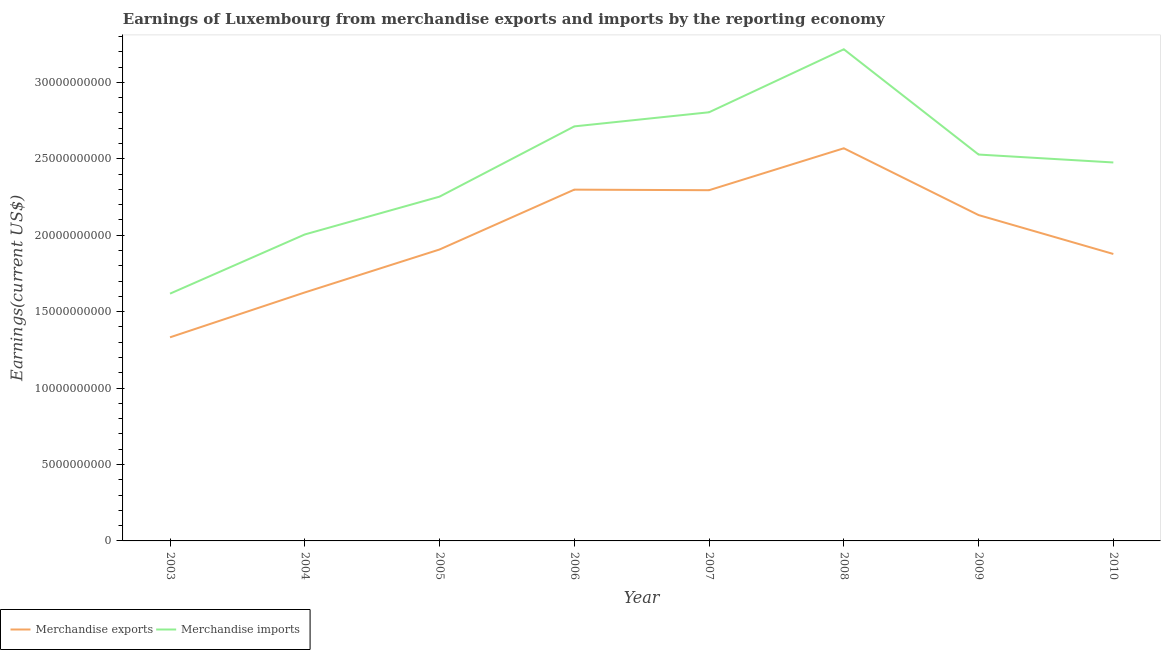How many different coloured lines are there?
Your answer should be very brief. 2. What is the earnings from merchandise imports in 2008?
Your answer should be compact. 3.22e+1. Across all years, what is the maximum earnings from merchandise imports?
Offer a terse response. 3.22e+1. Across all years, what is the minimum earnings from merchandise imports?
Your answer should be very brief. 1.62e+1. In which year was the earnings from merchandise imports maximum?
Make the answer very short. 2008. In which year was the earnings from merchandise exports minimum?
Provide a succinct answer. 2003. What is the total earnings from merchandise exports in the graph?
Your answer should be very brief. 1.60e+11. What is the difference between the earnings from merchandise exports in 2004 and that in 2008?
Provide a short and direct response. -9.43e+09. What is the difference between the earnings from merchandise imports in 2007 and the earnings from merchandise exports in 2010?
Your response must be concise. 9.27e+09. What is the average earnings from merchandise exports per year?
Offer a terse response. 2.00e+1. In the year 2008, what is the difference between the earnings from merchandise imports and earnings from merchandise exports?
Give a very brief answer. 6.48e+09. In how many years, is the earnings from merchandise exports greater than 25000000000 US$?
Make the answer very short. 1. What is the ratio of the earnings from merchandise exports in 2004 to that in 2006?
Offer a very short reply. 0.71. Is the earnings from merchandise imports in 2003 less than that in 2009?
Offer a very short reply. Yes. What is the difference between the highest and the second highest earnings from merchandise imports?
Provide a succinct answer. 4.12e+09. What is the difference between the highest and the lowest earnings from merchandise exports?
Your response must be concise. 1.24e+1. Is the sum of the earnings from merchandise imports in 2004 and 2010 greater than the maximum earnings from merchandise exports across all years?
Make the answer very short. Yes. Is the earnings from merchandise imports strictly greater than the earnings from merchandise exports over the years?
Ensure brevity in your answer.  Yes. Does the graph contain any zero values?
Provide a succinct answer. No. Does the graph contain grids?
Provide a succinct answer. No. Where does the legend appear in the graph?
Offer a very short reply. Bottom left. How many legend labels are there?
Provide a succinct answer. 2. How are the legend labels stacked?
Give a very brief answer. Horizontal. What is the title of the graph?
Offer a very short reply. Earnings of Luxembourg from merchandise exports and imports by the reporting economy. What is the label or title of the X-axis?
Offer a very short reply. Year. What is the label or title of the Y-axis?
Keep it short and to the point. Earnings(current US$). What is the Earnings(current US$) in Merchandise exports in 2003?
Keep it short and to the point. 1.33e+1. What is the Earnings(current US$) of Merchandise imports in 2003?
Give a very brief answer. 1.62e+1. What is the Earnings(current US$) in Merchandise exports in 2004?
Ensure brevity in your answer.  1.63e+1. What is the Earnings(current US$) in Merchandise imports in 2004?
Your response must be concise. 2.01e+1. What is the Earnings(current US$) of Merchandise exports in 2005?
Keep it short and to the point. 1.91e+1. What is the Earnings(current US$) of Merchandise imports in 2005?
Offer a terse response. 2.25e+1. What is the Earnings(current US$) of Merchandise exports in 2006?
Your response must be concise. 2.30e+1. What is the Earnings(current US$) of Merchandise imports in 2006?
Your answer should be compact. 2.71e+1. What is the Earnings(current US$) of Merchandise exports in 2007?
Your response must be concise. 2.29e+1. What is the Earnings(current US$) of Merchandise imports in 2007?
Keep it short and to the point. 2.80e+1. What is the Earnings(current US$) of Merchandise exports in 2008?
Make the answer very short. 2.57e+1. What is the Earnings(current US$) in Merchandise imports in 2008?
Offer a very short reply. 3.22e+1. What is the Earnings(current US$) of Merchandise exports in 2009?
Your answer should be very brief. 2.13e+1. What is the Earnings(current US$) in Merchandise imports in 2009?
Your answer should be very brief. 2.53e+1. What is the Earnings(current US$) in Merchandise exports in 2010?
Provide a succinct answer. 1.88e+1. What is the Earnings(current US$) of Merchandise imports in 2010?
Provide a short and direct response. 2.48e+1. Across all years, what is the maximum Earnings(current US$) in Merchandise exports?
Provide a succinct answer. 2.57e+1. Across all years, what is the maximum Earnings(current US$) in Merchandise imports?
Give a very brief answer. 3.22e+1. Across all years, what is the minimum Earnings(current US$) of Merchandise exports?
Ensure brevity in your answer.  1.33e+1. Across all years, what is the minimum Earnings(current US$) in Merchandise imports?
Give a very brief answer. 1.62e+1. What is the total Earnings(current US$) in Merchandise exports in the graph?
Provide a short and direct response. 1.60e+11. What is the total Earnings(current US$) in Merchandise imports in the graph?
Ensure brevity in your answer.  1.96e+11. What is the difference between the Earnings(current US$) of Merchandise exports in 2003 and that in 2004?
Keep it short and to the point. -2.94e+09. What is the difference between the Earnings(current US$) of Merchandise imports in 2003 and that in 2004?
Ensure brevity in your answer.  -3.87e+09. What is the difference between the Earnings(current US$) of Merchandise exports in 2003 and that in 2005?
Offer a very short reply. -5.75e+09. What is the difference between the Earnings(current US$) of Merchandise imports in 2003 and that in 2005?
Make the answer very short. -6.35e+09. What is the difference between the Earnings(current US$) of Merchandise exports in 2003 and that in 2006?
Your response must be concise. -9.66e+09. What is the difference between the Earnings(current US$) of Merchandise imports in 2003 and that in 2006?
Your answer should be compact. -1.09e+1. What is the difference between the Earnings(current US$) of Merchandise exports in 2003 and that in 2007?
Give a very brief answer. -9.63e+09. What is the difference between the Earnings(current US$) of Merchandise imports in 2003 and that in 2007?
Ensure brevity in your answer.  -1.19e+1. What is the difference between the Earnings(current US$) of Merchandise exports in 2003 and that in 2008?
Your response must be concise. -1.24e+1. What is the difference between the Earnings(current US$) in Merchandise imports in 2003 and that in 2008?
Ensure brevity in your answer.  -1.60e+1. What is the difference between the Earnings(current US$) of Merchandise exports in 2003 and that in 2009?
Give a very brief answer. -8.00e+09. What is the difference between the Earnings(current US$) in Merchandise imports in 2003 and that in 2009?
Your answer should be very brief. -9.10e+09. What is the difference between the Earnings(current US$) of Merchandise exports in 2003 and that in 2010?
Offer a very short reply. -5.45e+09. What is the difference between the Earnings(current US$) in Merchandise imports in 2003 and that in 2010?
Your answer should be compact. -8.58e+09. What is the difference between the Earnings(current US$) of Merchandise exports in 2004 and that in 2005?
Offer a very short reply. -2.81e+09. What is the difference between the Earnings(current US$) in Merchandise imports in 2004 and that in 2005?
Ensure brevity in your answer.  -2.47e+09. What is the difference between the Earnings(current US$) of Merchandise exports in 2004 and that in 2006?
Ensure brevity in your answer.  -6.73e+09. What is the difference between the Earnings(current US$) of Merchandise imports in 2004 and that in 2006?
Provide a short and direct response. -7.07e+09. What is the difference between the Earnings(current US$) of Merchandise exports in 2004 and that in 2007?
Your answer should be compact. -6.69e+09. What is the difference between the Earnings(current US$) in Merchandise imports in 2004 and that in 2007?
Your response must be concise. -7.99e+09. What is the difference between the Earnings(current US$) in Merchandise exports in 2004 and that in 2008?
Your answer should be very brief. -9.43e+09. What is the difference between the Earnings(current US$) in Merchandise imports in 2004 and that in 2008?
Keep it short and to the point. -1.21e+1. What is the difference between the Earnings(current US$) in Merchandise exports in 2004 and that in 2009?
Keep it short and to the point. -5.06e+09. What is the difference between the Earnings(current US$) of Merchandise imports in 2004 and that in 2009?
Offer a very short reply. -5.23e+09. What is the difference between the Earnings(current US$) of Merchandise exports in 2004 and that in 2010?
Your answer should be compact. -2.52e+09. What is the difference between the Earnings(current US$) in Merchandise imports in 2004 and that in 2010?
Give a very brief answer. -4.71e+09. What is the difference between the Earnings(current US$) in Merchandise exports in 2005 and that in 2006?
Provide a succinct answer. -3.92e+09. What is the difference between the Earnings(current US$) of Merchandise imports in 2005 and that in 2006?
Your answer should be compact. -4.60e+09. What is the difference between the Earnings(current US$) in Merchandise exports in 2005 and that in 2007?
Offer a terse response. -3.88e+09. What is the difference between the Earnings(current US$) in Merchandise imports in 2005 and that in 2007?
Make the answer very short. -5.52e+09. What is the difference between the Earnings(current US$) of Merchandise exports in 2005 and that in 2008?
Offer a very short reply. -6.62e+09. What is the difference between the Earnings(current US$) in Merchandise imports in 2005 and that in 2008?
Keep it short and to the point. -9.64e+09. What is the difference between the Earnings(current US$) in Merchandise exports in 2005 and that in 2009?
Provide a succinct answer. -2.25e+09. What is the difference between the Earnings(current US$) in Merchandise imports in 2005 and that in 2009?
Offer a terse response. -2.75e+09. What is the difference between the Earnings(current US$) in Merchandise exports in 2005 and that in 2010?
Provide a short and direct response. 2.94e+08. What is the difference between the Earnings(current US$) in Merchandise imports in 2005 and that in 2010?
Offer a very short reply. -2.24e+09. What is the difference between the Earnings(current US$) in Merchandise exports in 2006 and that in 2007?
Your answer should be compact. 3.70e+07. What is the difference between the Earnings(current US$) of Merchandise imports in 2006 and that in 2007?
Offer a very short reply. -9.23e+08. What is the difference between the Earnings(current US$) in Merchandise exports in 2006 and that in 2008?
Provide a short and direct response. -2.71e+09. What is the difference between the Earnings(current US$) in Merchandise imports in 2006 and that in 2008?
Offer a very short reply. -5.05e+09. What is the difference between the Earnings(current US$) in Merchandise exports in 2006 and that in 2009?
Make the answer very short. 1.66e+09. What is the difference between the Earnings(current US$) of Merchandise imports in 2006 and that in 2009?
Give a very brief answer. 1.84e+09. What is the difference between the Earnings(current US$) of Merchandise exports in 2006 and that in 2010?
Your response must be concise. 4.21e+09. What is the difference between the Earnings(current US$) in Merchandise imports in 2006 and that in 2010?
Offer a terse response. 2.36e+09. What is the difference between the Earnings(current US$) in Merchandise exports in 2007 and that in 2008?
Your answer should be compact. -2.74e+09. What is the difference between the Earnings(current US$) of Merchandise imports in 2007 and that in 2008?
Offer a very short reply. -4.12e+09. What is the difference between the Earnings(current US$) in Merchandise exports in 2007 and that in 2009?
Your response must be concise. 1.63e+09. What is the difference between the Earnings(current US$) in Merchandise imports in 2007 and that in 2009?
Provide a short and direct response. 2.77e+09. What is the difference between the Earnings(current US$) of Merchandise exports in 2007 and that in 2010?
Your answer should be very brief. 4.17e+09. What is the difference between the Earnings(current US$) in Merchandise imports in 2007 and that in 2010?
Give a very brief answer. 3.28e+09. What is the difference between the Earnings(current US$) of Merchandise exports in 2008 and that in 2009?
Your answer should be very brief. 4.37e+09. What is the difference between the Earnings(current US$) of Merchandise imports in 2008 and that in 2009?
Your answer should be compact. 6.89e+09. What is the difference between the Earnings(current US$) of Merchandise exports in 2008 and that in 2010?
Give a very brief answer. 6.92e+09. What is the difference between the Earnings(current US$) in Merchandise imports in 2008 and that in 2010?
Ensure brevity in your answer.  7.41e+09. What is the difference between the Earnings(current US$) of Merchandise exports in 2009 and that in 2010?
Provide a succinct answer. 2.55e+09. What is the difference between the Earnings(current US$) in Merchandise imports in 2009 and that in 2010?
Provide a short and direct response. 5.18e+08. What is the difference between the Earnings(current US$) of Merchandise exports in 2003 and the Earnings(current US$) of Merchandise imports in 2004?
Your response must be concise. -6.73e+09. What is the difference between the Earnings(current US$) in Merchandise exports in 2003 and the Earnings(current US$) in Merchandise imports in 2005?
Keep it short and to the point. -9.20e+09. What is the difference between the Earnings(current US$) in Merchandise exports in 2003 and the Earnings(current US$) in Merchandise imports in 2006?
Ensure brevity in your answer.  -1.38e+1. What is the difference between the Earnings(current US$) of Merchandise exports in 2003 and the Earnings(current US$) of Merchandise imports in 2007?
Your response must be concise. -1.47e+1. What is the difference between the Earnings(current US$) of Merchandise exports in 2003 and the Earnings(current US$) of Merchandise imports in 2008?
Offer a very short reply. -1.88e+1. What is the difference between the Earnings(current US$) in Merchandise exports in 2003 and the Earnings(current US$) in Merchandise imports in 2009?
Ensure brevity in your answer.  -1.20e+1. What is the difference between the Earnings(current US$) in Merchandise exports in 2003 and the Earnings(current US$) in Merchandise imports in 2010?
Your answer should be compact. -1.14e+1. What is the difference between the Earnings(current US$) of Merchandise exports in 2004 and the Earnings(current US$) of Merchandise imports in 2005?
Offer a terse response. -6.27e+09. What is the difference between the Earnings(current US$) in Merchandise exports in 2004 and the Earnings(current US$) in Merchandise imports in 2006?
Provide a succinct answer. -1.09e+1. What is the difference between the Earnings(current US$) of Merchandise exports in 2004 and the Earnings(current US$) of Merchandise imports in 2007?
Your answer should be compact. -1.18e+1. What is the difference between the Earnings(current US$) of Merchandise exports in 2004 and the Earnings(current US$) of Merchandise imports in 2008?
Give a very brief answer. -1.59e+1. What is the difference between the Earnings(current US$) of Merchandise exports in 2004 and the Earnings(current US$) of Merchandise imports in 2009?
Ensure brevity in your answer.  -9.02e+09. What is the difference between the Earnings(current US$) in Merchandise exports in 2004 and the Earnings(current US$) in Merchandise imports in 2010?
Keep it short and to the point. -8.51e+09. What is the difference between the Earnings(current US$) in Merchandise exports in 2005 and the Earnings(current US$) in Merchandise imports in 2006?
Your answer should be compact. -8.06e+09. What is the difference between the Earnings(current US$) in Merchandise exports in 2005 and the Earnings(current US$) in Merchandise imports in 2007?
Give a very brief answer. -8.98e+09. What is the difference between the Earnings(current US$) in Merchandise exports in 2005 and the Earnings(current US$) in Merchandise imports in 2008?
Provide a short and direct response. -1.31e+1. What is the difference between the Earnings(current US$) in Merchandise exports in 2005 and the Earnings(current US$) in Merchandise imports in 2009?
Provide a short and direct response. -6.21e+09. What is the difference between the Earnings(current US$) in Merchandise exports in 2005 and the Earnings(current US$) in Merchandise imports in 2010?
Offer a terse response. -5.69e+09. What is the difference between the Earnings(current US$) of Merchandise exports in 2006 and the Earnings(current US$) of Merchandise imports in 2007?
Your answer should be very brief. -5.06e+09. What is the difference between the Earnings(current US$) in Merchandise exports in 2006 and the Earnings(current US$) in Merchandise imports in 2008?
Make the answer very short. -9.18e+09. What is the difference between the Earnings(current US$) in Merchandise exports in 2006 and the Earnings(current US$) in Merchandise imports in 2009?
Ensure brevity in your answer.  -2.30e+09. What is the difference between the Earnings(current US$) of Merchandise exports in 2006 and the Earnings(current US$) of Merchandise imports in 2010?
Your answer should be compact. -1.78e+09. What is the difference between the Earnings(current US$) of Merchandise exports in 2007 and the Earnings(current US$) of Merchandise imports in 2008?
Keep it short and to the point. -9.22e+09. What is the difference between the Earnings(current US$) in Merchandise exports in 2007 and the Earnings(current US$) in Merchandise imports in 2009?
Offer a very short reply. -2.33e+09. What is the difference between the Earnings(current US$) in Merchandise exports in 2007 and the Earnings(current US$) in Merchandise imports in 2010?
Your answer should be compact. -1.81e+09. What is the difference between the Earnings(current US$) of Merchandise exports in 2008 and the Earnings(current US$) of Merchandise imports in 2009?
Keep it short and to the point. 4.10e+08. What is the difference between the Earnings(current US$) of Merchandise exports in 2008 and the Earnings(current US$) of Merchandise imports in 2010?
Make the answer very short. 9.28e+08. What is the difference between the Earnings(current US$) in Merchandise exports in 2009 and the Earnings(current US$) in Merchandise imports in 2010?
Offer a terse response. -3.44e+09. What is the average Earnings(current US$) in Merchandise exports per year?
Provide a succinct answer. 2.00e+1. What is the average Earnings(current US$) of Merchandise imports per year?
Give a very brief answer. 2.45e+1. In the year 2003, what is the difference between the Earnings(current US$) of Merchandise exports and Earnings(current US$) of Merchandise imports?
Provide a succinct answer. -2.86e+09. In the year 2004, what is the difference between the Earnings(current US$) of Merchandise exports and Earnings(current US$) of Merchandise imports?
Ensure brevity in your answer.  -3.79e+09. In the year 2005, what is the difference between the Earnings(current US$) in Merchandise exports and Earnings(current US$) in Merchandise imports?
Your response must be concise. -3.46e+09. In the year 2006, what is the difference between the Earnings(current US$) in Merchandise exports and Earnings(current US$) in Merchandise imports?
Keep it short and to the point. -4.14e+09. In the year 2007, what is the difference between the Earnings(current US$) of Merchandise exports and Earnings(current US$) of Merchandise imports?
Your answer should be compact. -5.10e+09. In the year 2008, what is the difference between the Earnings(current US$) of Merchandise exports and Earnings(current US$) of Merchandise imports?
Offer a terse response. -6.48e+09. In the year 2009, what is the difference between the Earnings(current US$) of Merchandise exports and Earnings(current US$) of Merchandise imports?
Keep it short and to the point. -3.96e+09. In the year 2010, what is the difference between the Earnings(current US$) in Merchandise exports and Earnings(current US$) in Merchandise imports?
Provide a short and direct response. -5.99e+09. What is the ratio of the Earnings(current US$) of Merchandise exports in 2003 to that in 2004?
Provide a short and direct response. 0.82. What is the ratio of the Earnings(current US$) of Merchandise imports in 2003 to that in 2004?
Make the answer very short. 0.81. What is the ratio of the Earnings(current US$) in Merchandise exports in 2003 to that in 2005?
Ensure brevity in your answer.  0.7. What is the ratio of the Earnings(current US$) in Merchandise imports in 2003 to that in 2005?
Offer a very short reply. 0.72. What is the ratio of the Earnings(current US$) of Merchandise exports in 2003 to that in 2006?
Give a very brief answer. 0.58. What is the ratio of the Earnings(current US$) of Merchandise imports in 2003 to that in 2006?
Give a very brief answer. 0.6. What is the ratio of the Earnings(current US$) in Merchandise exports in 2003 to that in 2007?
Provide a short and direct response. 0.58. What is the ratio of the Earnings(current US$) in Merchandise imports in 2003 to that in 2007?
Provide a short and direct response. 0.58. What is the ratio of the Earnings(current US$) of Merchandise exports in 2003 to that in 2008?
Keep it short and to the point. 0.52. What is the ratio of the Earnings(current US$) of Merchandise imports in 2003 to that in 2008?
Your response must be concise. 0.5. What is the ratio of the Earnings(current US$) in Merchandise exports in 2003 to that in 2009?
Your answer should be compact. 0.62. What is the ratio of the Earnings(current US$) in Merchandise imports in 2003 to that in 2009?
Offer a terse response. 0.64. What is the ratio of the Earnings(current US$) of Merchandise exports in 2003 to that in 2010?
Provide a short and direct response. 0.71. What is the ratio of the Earnings(current US$) in Merchandise imports in 2003 to that in 2010?
Your answer should be very brief. 0.65. What is the ratio of the Earnings(current US$) in Merchandise exports in 2004 to that in 2005?
Provide a succinct answer. 0.85. What is the ratio of the Earnings(current US$) in Merchandise imports in 2004 to that in 2005?
Make the answer very short. 0.89. What is the ratio of the Earnings(current US$) of Merchandise exports in 2004 to that in 2006?
Provide a succinct answer. 0.71. What is the ratio of the Earnings(current US$) in Merchandise imports in 2004 to that in 2006?
Your answer should be compact. 0.74. What is the ratio of the Earnings(current US$) in Merchandise exports in 2004 to that in 2007?
Ensure brevity in your answer.  0.71. What is the ratio of the Earnings(current US$) in Merchandise imports in 2004 to that in 2007?
Your answer should be compact. 0.71. What is the ratio of the Earnings(current US$) in Merchandise exports in 2004 to that in 2008?
Offer a very short reply. 0.63. What is the ratio of the Earnings(current US$) in Merchandise imports in 2004 to that in 2008?
Your answer should be very brief. 0.62. What is the ratio of the Earnings(current US$) in Merchandise exports in 2004 to that in 2009?
Offer a terse response. 0.76. What is the ratio of the Earnings(current US$) of Merchandise imports in 2004 to that in 2009?
Ensure brevity in your answer.  0.79. What is the ratio of the Earnings(current US$) in Merchandise exports in 2004 to that in 2010?
Your response must be concise. 0.87. What is the ratio of the Earnings(current US$) of Merchandise imports in 2004 to that in 2010?
Give a very brief answer. 0.81. What is the ratio of the Earnings(current US$) in Merchandise exports in 2005 to that in 2006?
Provide a succinct answer. 0.83. What is the ratio of the Earnings(current US$) of Merchandise imports in 2005 to that in 2006?
Provide a short and direct response. 0.83. What is the ratio of the Earnings(current US$) of Merchandise exports in 2005 to that in 2007?
Give a very brief answer. 0.83. What is the ratio of the Earnings(current US$) in Merchandise imports in 2005 to that in 2007?
Make the answer very short. 0.8. What is the ratio of the Earnings(current US$) of Merchandise exports in 2005 to that in 2008?
Keep it short and to the point. 0.74. What is the ratio of the Earnings(current US$) in Merchandise imports in 2005 to that in 2008?
Give a very brief answer. 0.7. What is the ratio of the Earnings(current US$) of Merchandise exports in 2005 to that in 2009?
Ensure brevity in your answer.  0.89. What is the ratio of the Earnings(current US$) of Merchandise imports in 2005 to that in 2009?
Offer a terse response. 0.89. What is the ratio of the Earnings(current US$) of Merchandise exports in 2005 to that in 2010?
Your answer should be very brief. 1.02. What is the ratio of the Earnings(current US$) of Merchandise imports in 2005 to that in 2010?
Give a very brief answer. 0.91. What is the ratio of the Earnings(current US$) in Merchandise imports in 2006 to that in 2007?
Keep it short and to the point. 0.97. What is the ratio of the Earnings(current US$) of Merchandise exports in 2006 to that in 2008?
Offer a very short reply. 0.89. What is the ratio of the Earnings(current US$) of Merchandise imports in 2006 to that in 2008?
Give a very brief answer. 0.84. What is the ratio of the Earnings(current US$) in Merchandise exports in 2006 to that in 2009?
Make the answer very short. 1.08. What is the ratio of the Earnings(current US$) of Merchandise imports in 2006 to that in 2009?
Provide a succinct answer. 1.07. What is the ratio of the Earnings(current US$) in Merchandise exports in 2006 to that in 2010?
Provide a succinct answer. 1.22. What is the ratio of the Earnings(current US$) in Merchandise imports in 2006 to that in 2010?
Give a very brief answer. 1.1. What is the ratio of the Earnings(current US$) of Merchandise exports in 2007 to that in 2008?
Provide a succinct answer. 0.89. What is the ratio of the Earnings(current US$) in Merchandise imports in 2007 to that in 2008?
Provide a succinct answer. 0.87. What is the ratio of the Earnings(current US$) in Merchandise exports in 2007 to that in 2009?
Give a very brief answer. 1.08. What is the ratio of the Earnings(current US$) of Merchandise imports in 2007 to that in 2009?
Provide a succinct answer. 1.11. What is the ratio of the Earnings(current US$) of Merchandise exports in 2007 to that in 2010?
Keep it short and to the point. 1.22. What is the ratio of the Earnings(current US$) of Merchandise imports in 2007 to that in 2010?
Give a very brief answer. 1.13. What is the ratio of the Earnings(current US$) of Merchandise exports in 2008 to that in 2009?
Ensure brevity in your answer.  1.21. What is the ratio of the Earnings(current US$) in Merchandise imports in 2008 to that in 2009?
Make the answer very short. 1.27. What is the ratio of the Earnings(current US$) in Merchandise exports in 2008 to that in 2010?
Offer a very short reply. 1.37. What is the ratio of the Earnings(current US$) in Merchandise imports in 2008 to that in 2010?
Provide a succinct answer. 1.3. What is the ratio of the Earnings(current US$) of Merchandise exports in 2009 to that in 2010?
Your response must be concise. 1.14. What is the ratio of the Earnings(current US$) of Merchandise imports in 2009 to that in 2010?
Make the answer very short. 1.02. What is the difference between the highest and the second highest Earnings(current US$) of Merchandise exports?
Offer a very short reply. 2.71e+09. What is the difference between the highest and the second highest Earnings(current US$) of Merchandise imports?
Provide a succinct answer. 4.12e+09. What is the difference between the highest and the lowest Earnings(current US$) in Merchandise exports?
Your answer should be compact. 1.24e+1. What is the difference between the highest and the lowest Earnings(current US$) in Merchandise imports?
Give a very brief answer. 1.60e+1. 